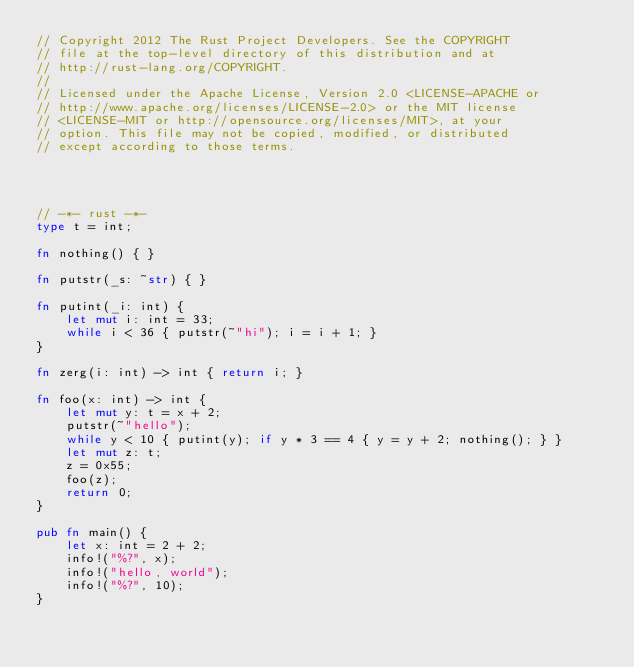Convert code to text. <code><loc_0><loc_0><loc_500><loc_500><_Rust_>// Copyright 2012 The Rust Project Developers. See the COPYRIGHT
// file at the top-level directory of this distribution and at
// http://rust-lang.org/COPYRIGHT.
//
// Licensed under the Apache License, Version 2.0 <LICENSE-APACHE or
// http://www.apache.org/licenses/LICENSE-2.0> or the MIT license
// <LICENSE-MIT or http://opensource.org/licenses/MIT>, at your
// option. This file may not be copied, modified, or distributed
// except according to those terms.




// -*- rust -*-
type t = int;

fn nothing() { }

fn putstr(_s: ~str) { }

fn putint(_i: int) {
    let mut i: int = 33;
    while i < 36 { putstr(~"hi"); i = i + 1; }
}

fn zerg(i: int) -> int { return i; }

fn foo(x: int) -> int {
    let mut y: t = x + 2;
    putstr(~"hello");
    while y < 10 { putint(y); if y * 3 == 4 { y = y + 2; nothing(); } }
    let mut z: t;
    z = 0x55;
    foo(z);
    return 0;
}

pub fn main() {
    let x: int = 2 + 2;
    info!("%?", x);
    info!("hello, world");
    info!("%?", 10);
}
</code> 